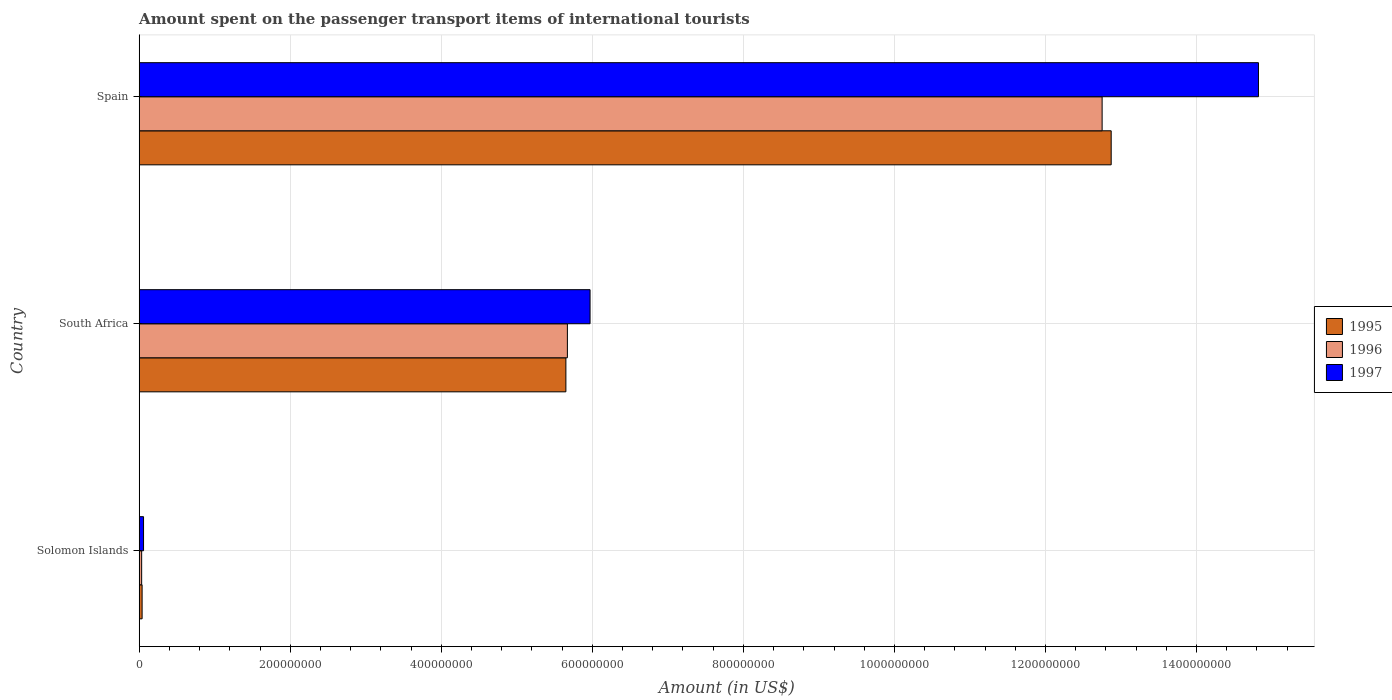How many groups of bars are there?
Give a very brief answer. 3. Are the number of bars per tick equal to the number of legend labels?
Offer a terse response. Yes. Are the number of bars on each tick of the Y-axis equal?
Provide a short and direct response. Yes. How many bars are there on the 2nd tick from the bottom?
Keep it short and to the point. 3. What is the label of the 3rd group of bars from the top?
Offer a very short reply. Solomon Islands. In how many cases, is the number of bars for a given country not equal to the number of legend labels?
Make the answer very short. 0. What is the amount spent on the passenger transport items of international tourists in 1996 in Solomon Islands?
Provide a succinct answer. 3.30e+06. Across all countries, what is the maximum amount spent on the passenger transport items of international tourists in 1996?
Provide a succinct answer. 1.28e+09. Across all countries, what is the minimum amount spent on the passenger transport items of international tourists in 1996?
Ensure brevity in your answer.  3.30e+06. In which country was the amount spent on the passenger transport items of international tourists in 1996 minimum?
Ensure brevity in your answer.  Solomon Islands. What is the total amount spent on the passenger transport items of international tourists in 1997 in the graph?
Your answer should be compact. 2.08e+09. What is the difference between the amount spent on the passenger transport items of international tourists in 1995 in Solomon Islands and that in South Africa?
Keep it short and to the point. -5.61e+08. What is the difference between the amount spent on the passenger transport items of international tourists in 1995 in Solomon Islands and the amount spent on the passenger transport items of international tourists in 1997 in South Africa?
Give a very brief answer. -5.93e+08. What is the average amount spent on the passenger transport items of international tourists in 1995 per country?
Your answer should be very brief. 6.19e+08. What is the difference between the amount spent on the passenger transport items of international tourists in 1997 and amount spent on the passenger transport items of international tourists in 1996 in South Africa?
Give a very brief answer. 3.00e+07. What is the ratio of the amount spent on the passenger transport items of international tourists in 1996 in Solomon Islands to that in Spain?
Make the answer very short. 0. Is the difference between the amount spent on the passenger transport items of international tourists in 1997 in South Africa and Spain greater than the difference between the amount spent on the passenger transport items of international tourists in 1996 in South Africa and Spain?
Make the answer very short. No. What is the difference between the highest and the second highest amount spent on the passenger transport items of international tourists in 1995?
Give a very brief answer. 7.22e+08. What is the difference between the highest and the lowest amount spent on the passenger transport items of international tourists in 1995?
Your answer should be very brief. 1.28e+09. What does the 2nd bar from the bottom in Solomon Islands represents?
Your response must be concise. 1996. Is it the case that in every country, the sum of the amount spent on the passenger transport items of international tourists in 1997 and amount spent on the passenger transport items of international tourists in 1996 is greater than the amount spent on the passenger transport items of international tourists in 1995?
Offer a terse response. Yes. How many countries are there in the graph?
Offer a terse response. 3. What is the difference between two consecutive major ticks on the X-axis?
Your response must be concise. 2.00e+08. Are the values on the major ticks of X-axis written in scientific E-notation?
Make the answer very short. No. Does the graph contain any zero values?
Offer a terse response. No. Where does the legend appear in the graph?
Provide a succinct answer. Center right. How many legend labels are there?
Ensure brevity in your answer.  3. How are the legend labels stacked?
Provide a short and direct response. Vertical. What is the title of the graph?
Keep it short and to the point. Amount spent on the passenger transport items of international tourists. Does "2012" appear as one of the legend labels in the graph?
Provide a succinct answer. No. What is the label or title of the Y-axis?
Make the answer very short. Country. What is the Amount (in US$) of 1995 in Solomon Islands?
Keep it short and to the point. 3.90e+06. What is the Amount (in US$) of 1996 in Solomon Islands?
Your answer should be compact. 3.30e+06. What is the Amount (in US$) in 1997 in Solomon Islands?
Your response must be concise. 5.80e+06. What is the Amount (in US$) in 1995 in South Africa?
Provide a succinct answer. 5.65e+08. What is the Amount (in US$) of 1996 in South Africa?
Make the answer very short. 5.67e+08. What is the Amount (in US$) of 1997 in South Africa?
Offer a terse response. 5.97e+08. What is the Amount (in US$) of 1995 in Spain?
Your response must be concise. 1.29e+09. What is the Amount (in US$) of 1996 in Spain?
Offer a very short reply. 1.28e+09. What is the Amount (in US$) in 1997 in Spain?
Keep it short and to the point. 1.48e+09. Across all countries, what is the maximum Amount (in US$) of 1995?
Keep it short and to the point. 1.29e+09. Across all countries, what is the maximum Amount (in US$) of 1996?
Offer a terse response. 1.28e+09. Across all countries, what is the maximum Amount (in US$) in 1997?
Offer a very short reply. 1.48e+09. Across all countries, what is the minimum Amount (in US$) in 1995?
Offer a terse response. 3.90e+06. Across all countries, what is the minimum Amount (in US$) in 1996?
Provide a succinct answer. 3.30e+06. Across all countries, what is the minimum Amount (in US$) of 1997?
Your response must be concise. 5.80e+06. What is the total Amount (in US$) of 1995 in the graph?
Offer a very short reply. 1.86e+09. What is the total Amount (in US$) in 1996 in the graph?
Provide a succinct answer. 1.85e+09. What is the total Amount (in US$) of 1997 in the graph?
Offer a very short reply. 2.08e+09. What is the difference between the Amount (in US$) of 1995 in Solomon Islands and that in South Africa?
Provide a succinct answer. -5.61e+08. What is the difference between the Amount (in US$) of 1996 in Solomon Islands and that in South Africa?
Ensure brevity in your answer.  -5.64e+08. What is the difference between the Amount (in US$) of 1997 in Solomon Islands and that in South Africa?
Your answer should be very brief. -5.91e+08. What is the difference between the Amount (in US$) in 1995 in Solomon Islands and that in Spain?
Offer a very short reply. -1.28e+09. What is the difference between the Amount (in US$) in 1996 in Solomon Islands and that in Spain?
Keep it short and to the point. -1.27e+09. What is the difference between the Amount (in US$) in 1997 in Solomon Islands and that in Spain?
Ensure brevity in your answer.  -1.48e+09. What is the difference between the Amount (in US$) in 1995 in South Africa and that in Spain?
Keep it short and to the point. -7.22e+08. What is the difference between the Amount (in US$) of 1996 in South Africa and that in Spain?
Ensure brevity in your answer.  -7.08e+08. What is the difference between the Amount (in US$) of 1997 in South Africa and that in Spain?
Offer a terse response. -8.85e+08. What is the difference between the Amount (in US$) of 1995 in Solomon Islands and the Amount (in US$) of 1996 in South Africa?
Your answer should be compact. -5.63e+08. What is the difference between the Amount (in US$) in 1995 in Solomon Islands and the Amount (in US$) in 1997 in South Africa?
Offer a very short reply. -5.93e+08. What is the difference between the Amount (in US$) in 1996 in Solomon Islands and the Amount (in US$) in 1997 in South Africa?
Provide a succinct answer. -5.94e+08. What is the difference between the Amount (in US$) of 1995 in Solomon Islands and the Amount (in US$) of 1996 in Spain?
Ensure brevity in your answer.  -1.27e+09. What is the difference between the Amount (in US$) of 1995 in Solomon Islands and the Amount (in US$) of 1997 in Spain?
Give a very brief answer. -1.48e+09. What is the difference between the Amount (in US$) of 1996 in Solomon Islands and the Amount (in US$) of 1997 in Spain?
Ensure brevity in your answer.  -1.48e+09. What is the difference between the Amount (in US$) of 1995 in South Africa and the Amount (in US$) of 1996 in Spain?
Ensure brevity in your answer.  -7.10e+08. What is the difference between the Amount (in US$) of 1995 in South Africa and the Amount (in US$) of 1997 in Spain?
Keep it short and to the point. -9.17e+08. What is the difference between the Amount (in US$) in 1996 in South Africa and the Amount (in US$) in 1997 in Spain?
Keep it short and to the point. -9.15e+08. What is the average Amount (in US$) in 1995 per country?
Keep it short and to the point. 6.19e+08. What is the average Amount (in US$) of 1996 per country?
Your answer should be compact. 6.15e+08. What is the average Amount (in US$) of 1997 per country?
Provide a short and direct response. 6.95e+08. What is the difference between the Amount (in US$) in 1995 and Amount (in US$) in 1997 in Solomon Islands?
Offer a terse response. -1.90e+06. What is the difference between the Amount (in US$) of 1996 and Amount (in US$) of 1997 in Solomon Islands?
Provide a succinct answer. -2.50e+06. What is the difference between the Amount (in US$) of 1995 and Amount (in US$) of 1996 in South Africa?
Provide a succinct answer. -2.00e+06. What is the difference between the Amount (in US$) of 1995 and Amount (in US$) of 1997 in South Africa?
Your answer should be compact. -3.20e+07. What is the difference between the Amount (in US$) of 1996 and Amount (in US$) of 1997 in South Africa?
Your response must be concise. -3.00e+07. What is the difference between the Amount (in US$) in 1995 and Amount (in US$) in 1997 in Spain?
Give a very brief answer. -1.95e+08. What is the difference between the Amount (in US$) of 1996 and Amount (in US$) of 1997 in Spain?
Your response must be concise. -2.07e+08. What is the ratio of the Amount (in US$) in 1995 in Solomon Islands to that in South Africa?
Provide a short and direct response. 0.01. What is the ratio of the Amount (in US$) in 1996 in Solomon Islands to that in South Africa?
Keep it short and to the point. 0.01. What is the ratio of the Amount (in US$) of 1997 in Solomon Islands to that in South Africa?
Provide a short and direct response. 0.01. What is the ratio of the Amount (in US$) in 1995 in Solomon Islands to that in Spain?
Keep it short and to the point. 0. What is the ratio of the Amount (in US$) in 1996 in Solomon Islands to that in Spain?
Your response must be concise. 0. What is the ratio of the Amount (in US$) in 1997 in Solomon Islands to that in Spain?
Your answer should be compact. 0. What is the ratio of the Amount (in US$) of 1995 in South Africa to that in Spain?
Give a very brief answer. 0.44. What is the ratio of the Amount (in US$) of 1996 in South Africa to that in Spain?
Offer a very short reply. 0.44. What is the ratio of the Amount (in US$) in 1997 in South Africa to that in Spain?
Your answer should be very brief. 0.4. What is the difference between the highest and the second highest Amount (in US$) of 1995?
Provide a short and direct response. 7.22e+08. What is the difference between the highest and the second highest Amount (in US$) in 1996?
Give a very brief answer. 7.08e+08. What is the difference between the highest and the second highest Amount (in US$) in 1997?
Provide a succinct answer. 8.85e+08. What is the difference between the highest and the lowest Amount (in US$) in 1995?
Ensure brevity in your answer.  1.28e+09. What is the difference between the highest and the lowest Amount (in US$) in 1996?
Keep it short and to the point. 1.27e+09. What is the difference between the highest and the lowest Amount (in US$) in 1997?
Provide a short and direct response. 1.48e+09. 